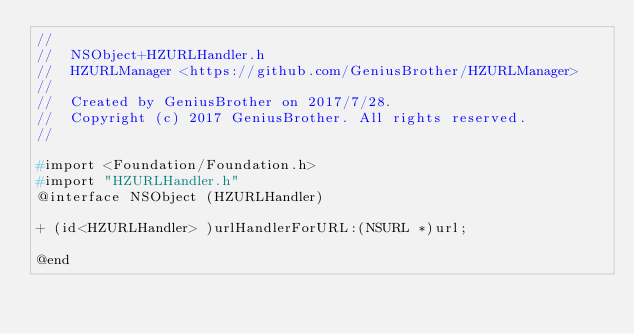<code> <loc_0><loc_0><loc_500><loc_500><_C_>//
//  NSObject+HZURLHandler.h
//  HZURLManager <https://github.com/GeniusBrother/HZURLManager>
//
//  Created by GeniusBrother on 2017/7/28.
//  Copyright (c) 2017 GeniusBrother. All rights reserved.
//

#import <Foundation/Foundation.h>
#import "HZURLHandler.h"
@interface NSObject (HZURLHandler)

+ (id<HZURLHandler> )urlHandlerForURL:(NSURL *)url;

@end
</code> 